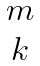<formula> <loc_0><loc_0><loc_500><loc_500>\begin{matrix} m \\ k \end{matrix}</formula> 